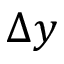Convert formula to latex. <formula><loc_0><loc_0><loc_500><loc_500>\Delta y</formula> 